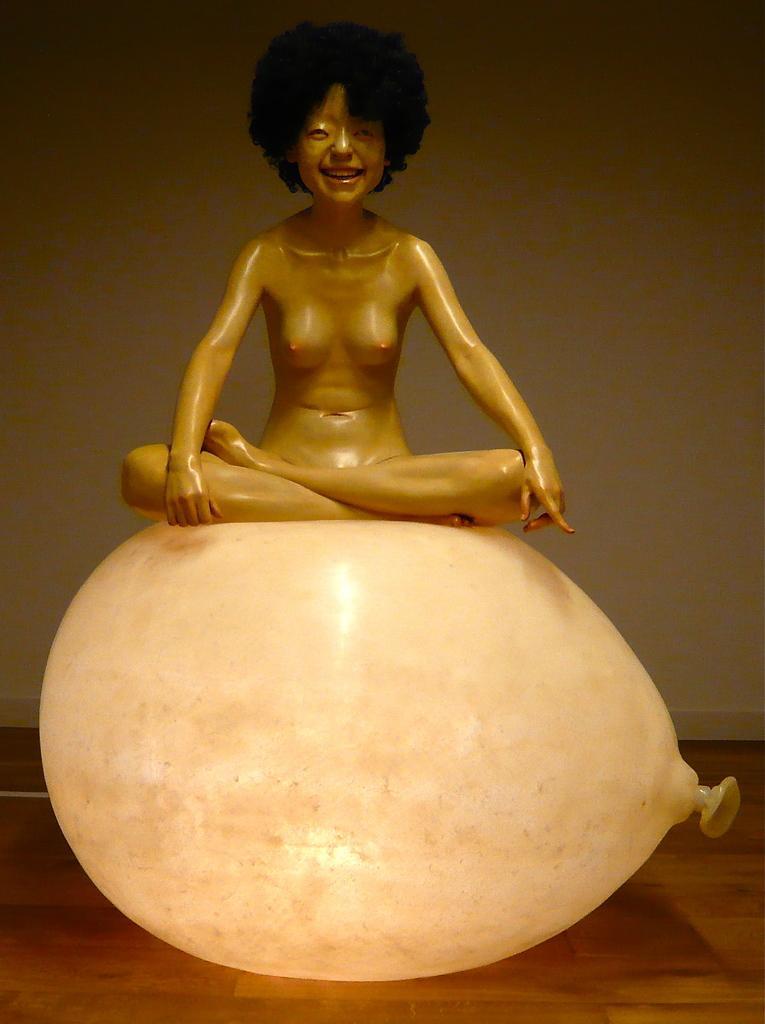Describe this image in one or two sentences. In this image in the middle, there is a toy on the balloon. At the bottom there is floor. In the background there is wall. 